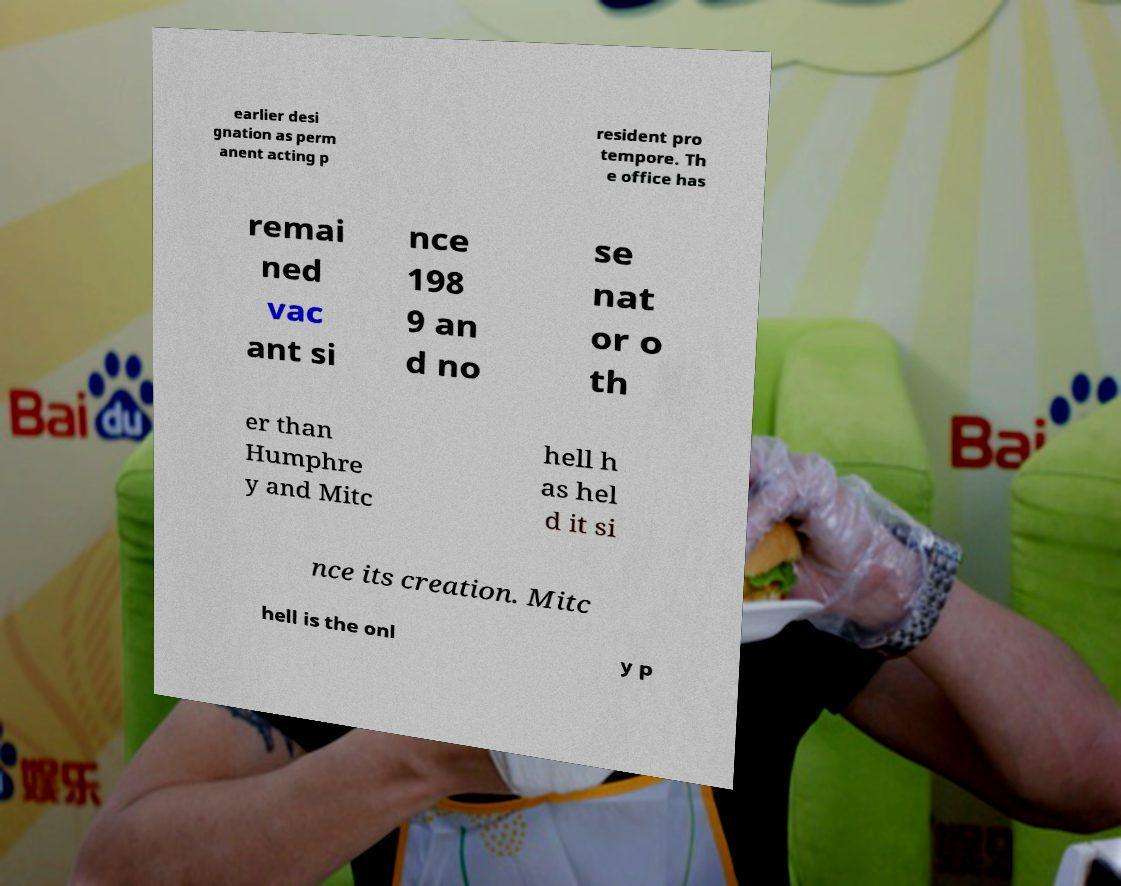Please identify and transcribe the text found in this image. earlier desi gnation as perm anent acting p resident pro tempore. Th e office has remai ned vac ant si nce 198 9 an d no se nat or o th er than Humphre y and Mitc hell h as hel d it si nce its creation. Mitc hell is the onl y p 